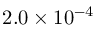Convert formula to latex. <formula><loc_0><loc_0><loc_500><loc_500>2 . 0 \times 1 0 ^ { - 4 }</formula> 